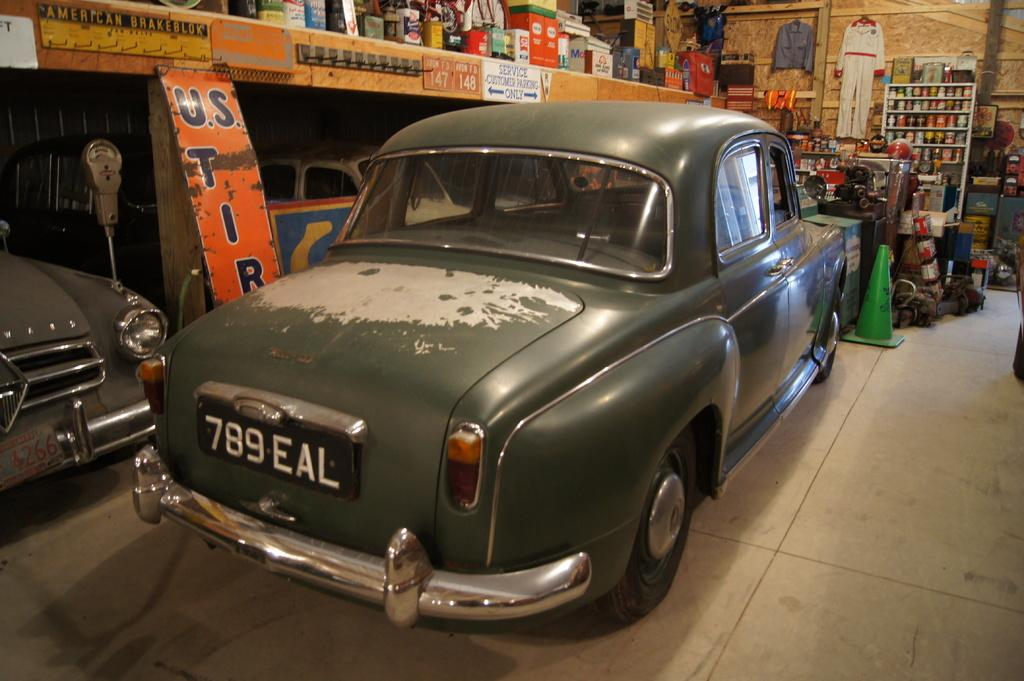What type of vehicles can be seen in the image? There are cars in the image. What else is present in the image besides cars? There are banners, boxes, a wall, a traffic cone, and cloths in the image. Can you describe the arrangement of the boxes in the image? There is a rack filled with boxes in the image. What type of stocking is hanging from the wall in the image? There is no stocking hanging from the wall in the image. What word is written on the banners in the image? The provided facts do not mention any specific words on the banners, so we cannot answer this question definitively. 